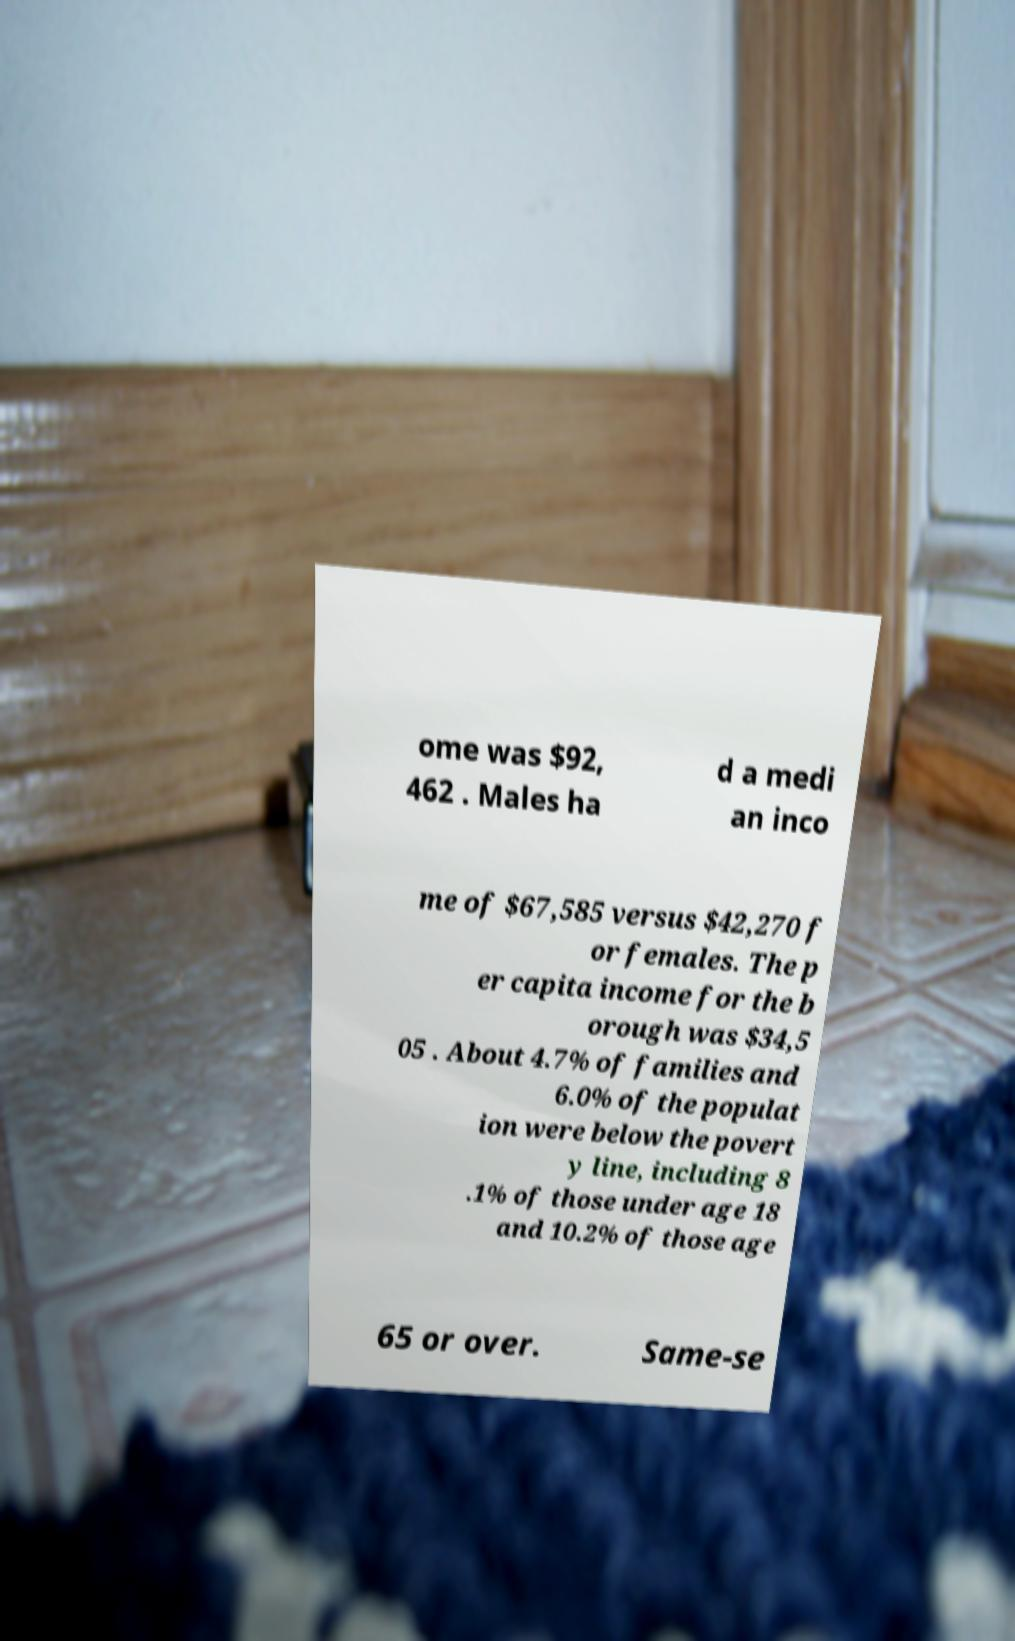Can you accurately transcribe the text from the provided image for me? ome was $92, 462 . Males ha d a medi an inco me of $67,585 versus $42,270 f or females. The p er capita income for the b orough was $34,5 05 . About 4.7% of families and 6.0% of the populat ion were below the povert y line, including 8 .1% of those under age 18 and 10.2% of those age 65 or over. Same-se 